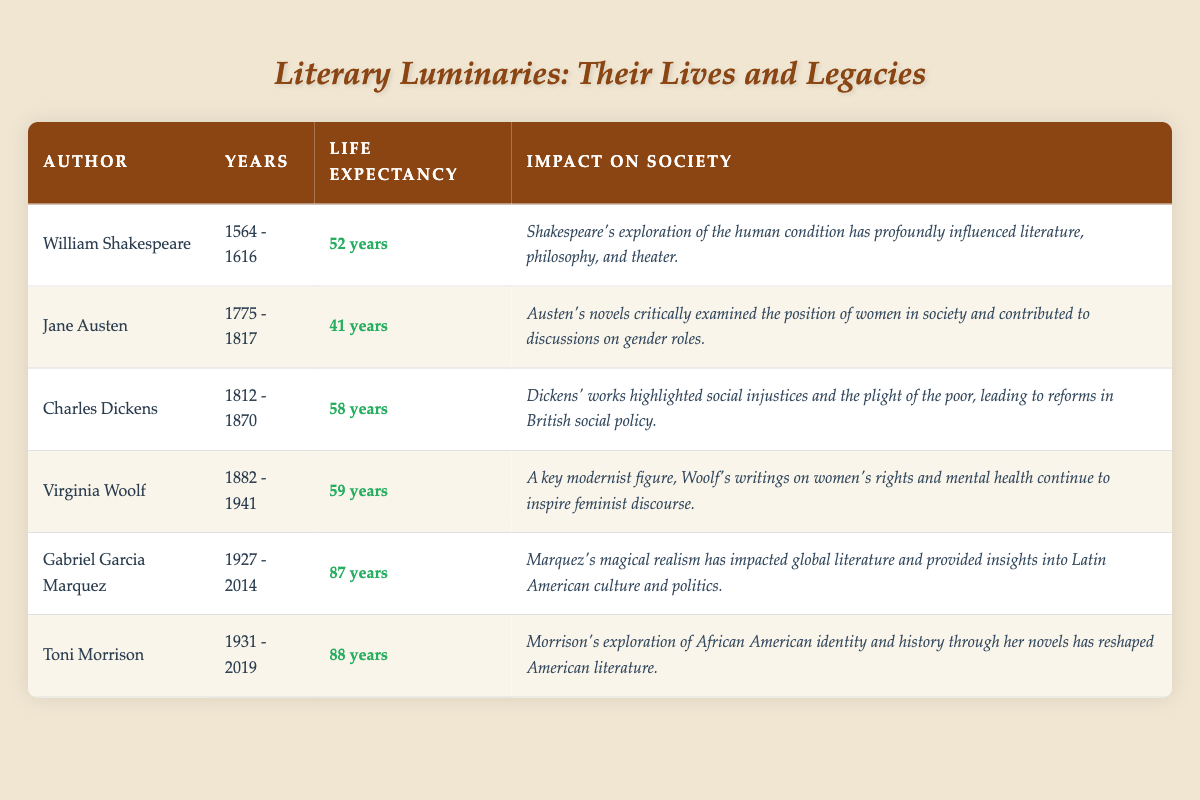What is the life expectancy of Charles Dickens? Charles Dickens' life expectancy is stated in the table as 58 years. You can find this information directly under the "Life Expectancy" column corresponding to his name in the "Author" column.
Answer: 58 years Which author had the longest life expectancy? To find the longest life expectancy, we look at the "Life Expectancy" column and compare the figures. Gabriel Garcia Marquez has a life expectancy of 87 years, which is the highest among all authors listed.
Answer: 87 years Was Jane Austen's life expectancy above or below the average life expectancy of the authors listed? First, we need to calculate the average life expectancy of all listed authors. The sum of the life expectancies is 52 + 41 + 58 + 59 + 87 + 88 = 385. There are 6 authors, so the average is 385/6 ≈ 64.17. Jane Austen's life expectancy is 41 years, which is below this average.
Answer: Below How much longer did Toni Morrison live compared to William Shakespeare? Toni Morrison lived to be 88 years old, while William Shakespeare's life expectancy was 52 years. To find the difference, we subtract Shakespeare's life expectancy from Morrison's: 88 - 52 = 36. Therefore, Morrison lived 36 years longer than Shakespeare.
Answer: 36 years Is the impact of Virginia Woolf's works considered significant in the realm of women's rights? The table describes Virginia Woolf as a key modernist figure whose writings on women's rights continue to inspire feminist discourse. This implies that her impact on women's rights is significant.
Answer: Yes What is the average life expectancy of authors from the 20th century (i.e., after 1900)? The authors from the 20th century in the table are Virginia Woolf (59 years), Gabriel Garcia Marquez (87 years), and Toni Morrison (88 years). We find the average by adding these life expectancies: 59 + 87 + 88 = 234. Then we divide by the number of authors (3): 234/3 = 78. Therefore, the average life expectancy of 20th-century authors is 78 years.
Answer: 78 years 